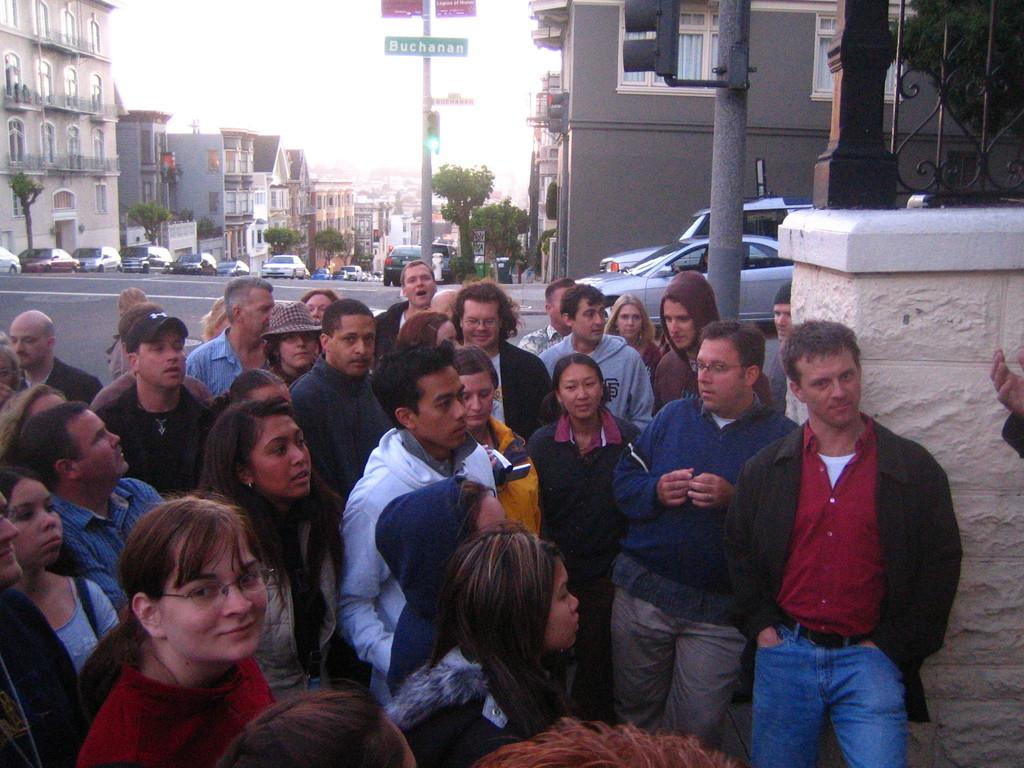How many people are in the image? There is a group of people in the image. What are the people in the image doing? The people are standing. What can be seen in the background of the image? There are sign boards, poles, traffic lights, trees, and buildings in the background of the image. What else can be seen on the road in the background of the image? There are vehicles on the road in the background of the image. What year is depicted in the image? The image does not depict a specific year; it is a snapshot of a scene at a particular moment. What type of minister is present in the image? There is no minister present in the image. What season is suggested by the image? The image does not provide enough information to determine the season; it could be any time of year. 